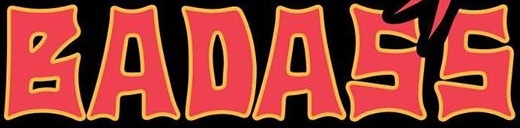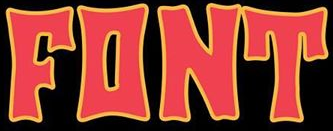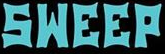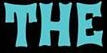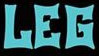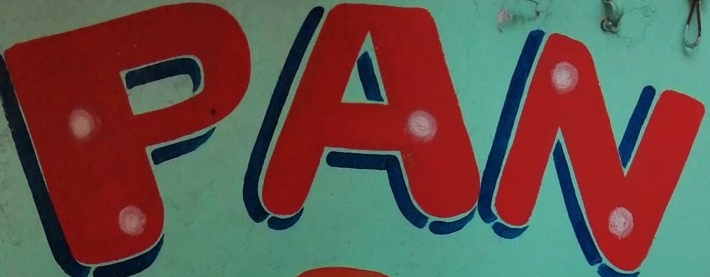Read the text from these images in sequence, separated by a semicolon. BADASS; FONT; SWEEP; THE; LEG; PAN 